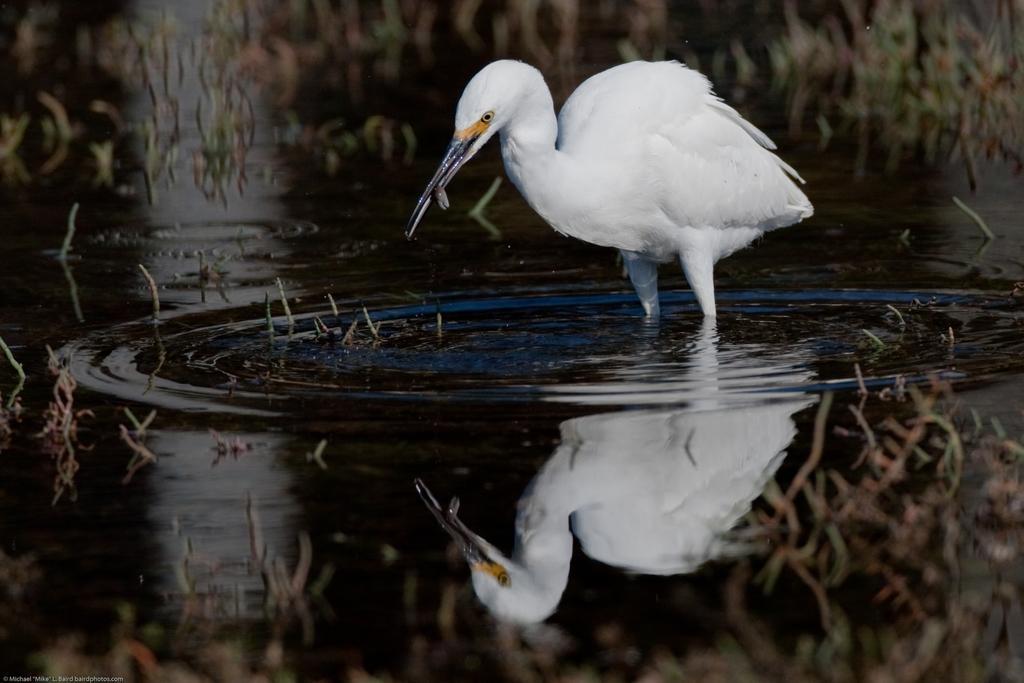Please provide a concise description of this image. In the center of the image, we can see a crane and at the bottom, there is water. 